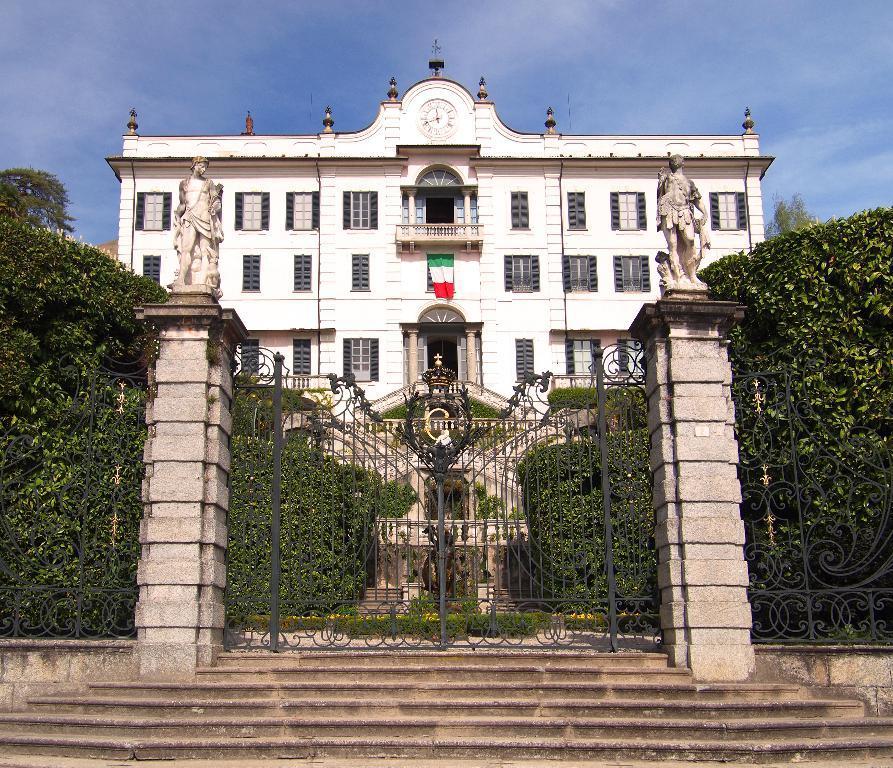In one or two sentences, can you explain what this image depicts? In this image I can see an iron gate and the stairs in the front. On the both sides of the image I can see bushes and two sculptures. In the background I can see a building, number of windows, a flag, clouds and the sky. On the top side of the building I can see a clock. 